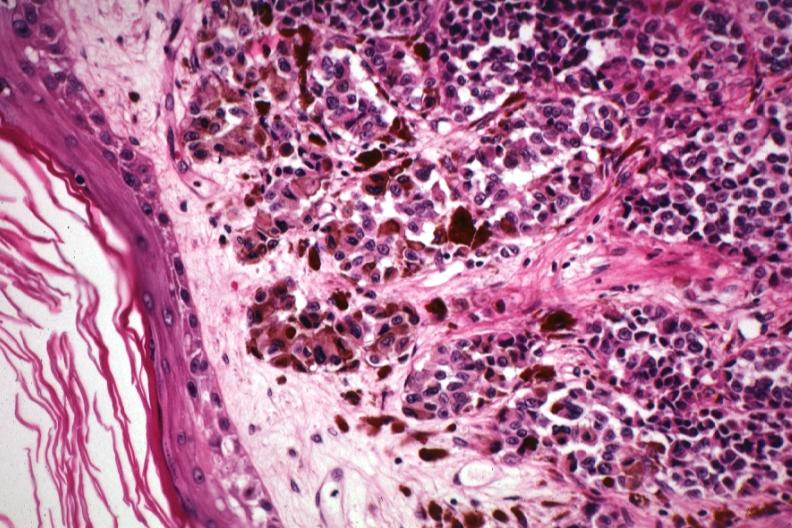what does this image show?
Answer the question using a single word or phrase. Excellent showing lesion just beneath epidermis with pigmented and non-pigmented cells 